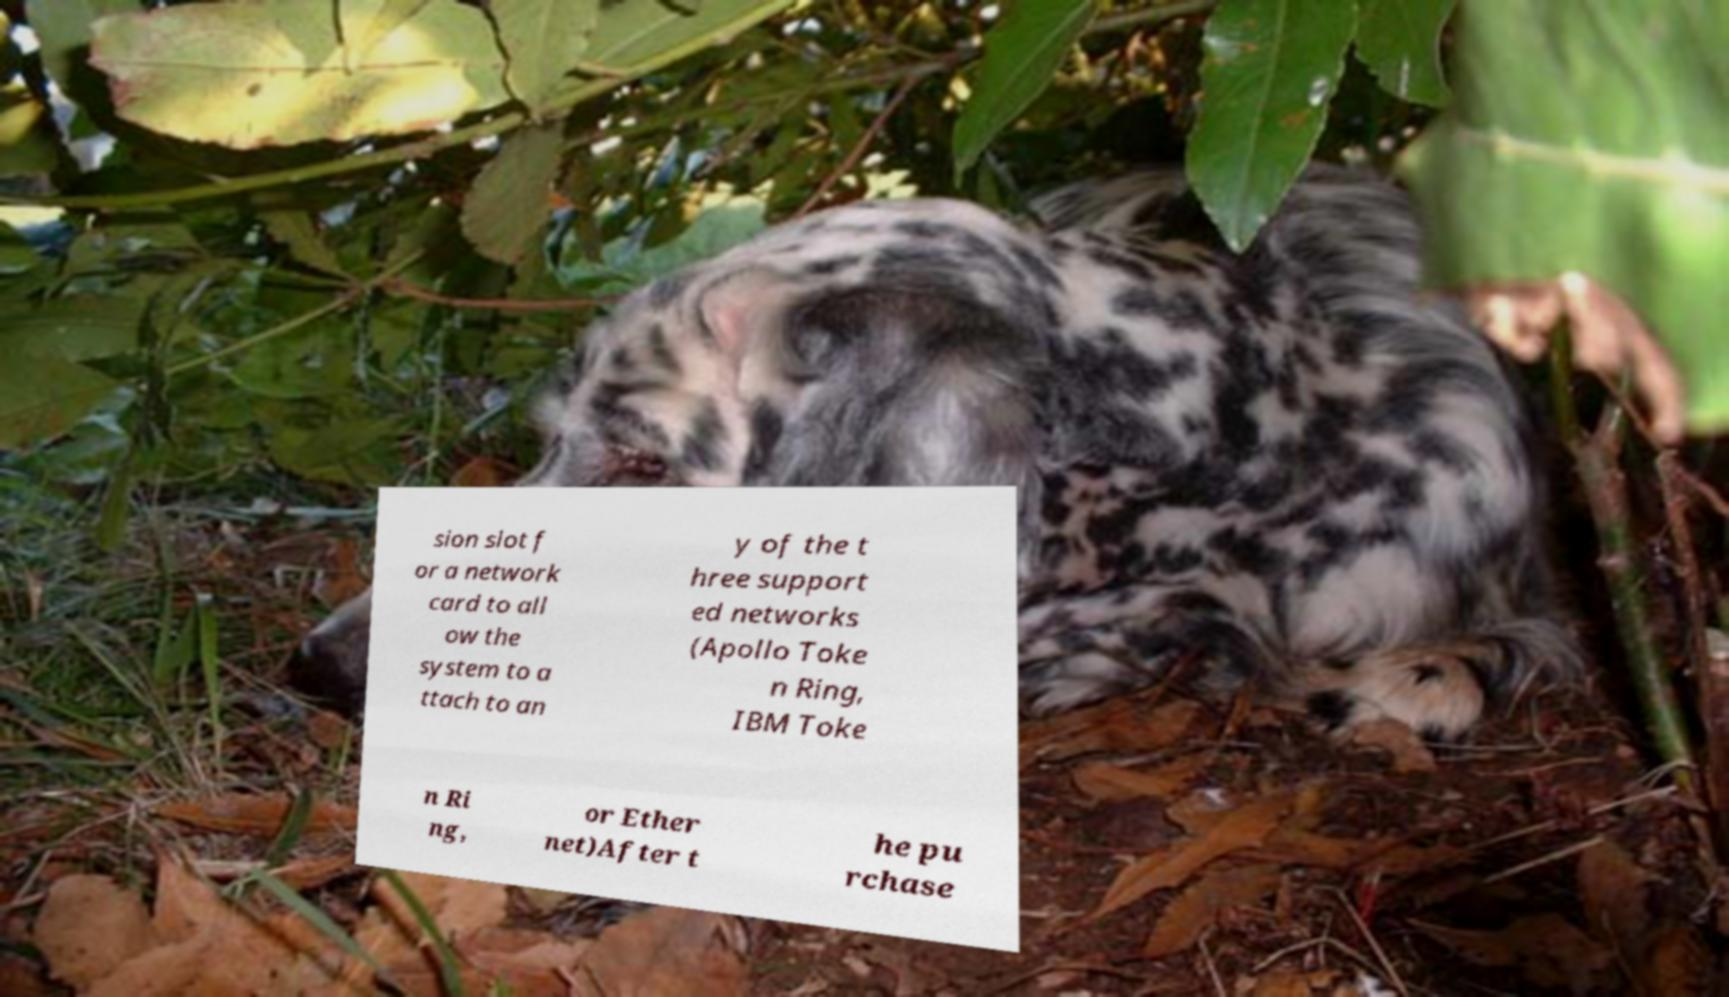There's text embedded in this image that I need extracted. Can you transcribe it verbatim? sion slot f or a network card to all ow the system to a ttach to an y of the t hree support ed networks (Apollo Toke n Ring, IBM Toke n Ri ng, or Ether net)After t he pu rchase 